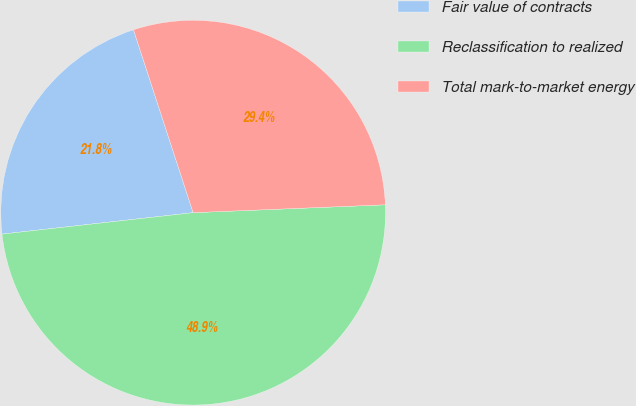Convert chart. <chart><loc_0><loc_0><loc_500><loc_500><pie_chart><fcel>Fair value of contracts<fcel>Reclassification to realized<fcel>Total mark-to-market energy<nl><fcel>21.76%<fcel>48.87%<fcel>29.36%<nl></chart> 